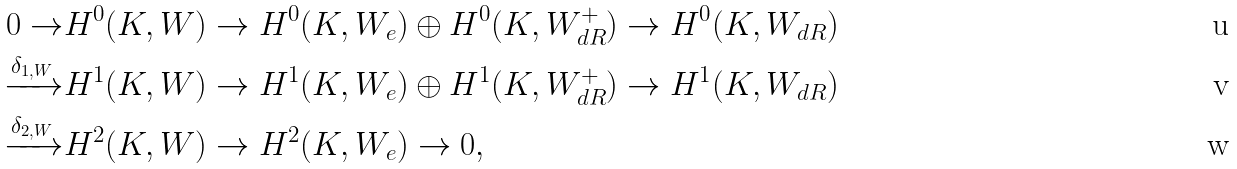Convert formula to latex. <formula><loc_0><loc_0><loc_500><loc_500>0 \rightarrow & H ^ { 0 } ( K , W ) \rightarrow H ^ { 0 } ( K , W _ { e } ) \oplus H ^ { 0 } ( K , W ^ { + } _ { d R } ) \rightarrow H ^ { 0 } ( K , W _ { d R } ) \\ \xrightarrow { \delta _ { 1 , W } } & H ^ { 1 } ( K , W ) \rightarrow H ^ { 1 } ( K , W _ { e } ) \oplus H ^ { 1 } ( K , W ^ { + } _ { d R } ) \rightarrow H ^ { 1 } ( K , W _ { d R } ) \\ \xrightarrow { \delta _ { 2 , W } } & H ^ { 2 } ( K , W ) \rightarrow H ^ { 2 } ( K , W _ { e } ) \rightarrow 0 ,</formula> 